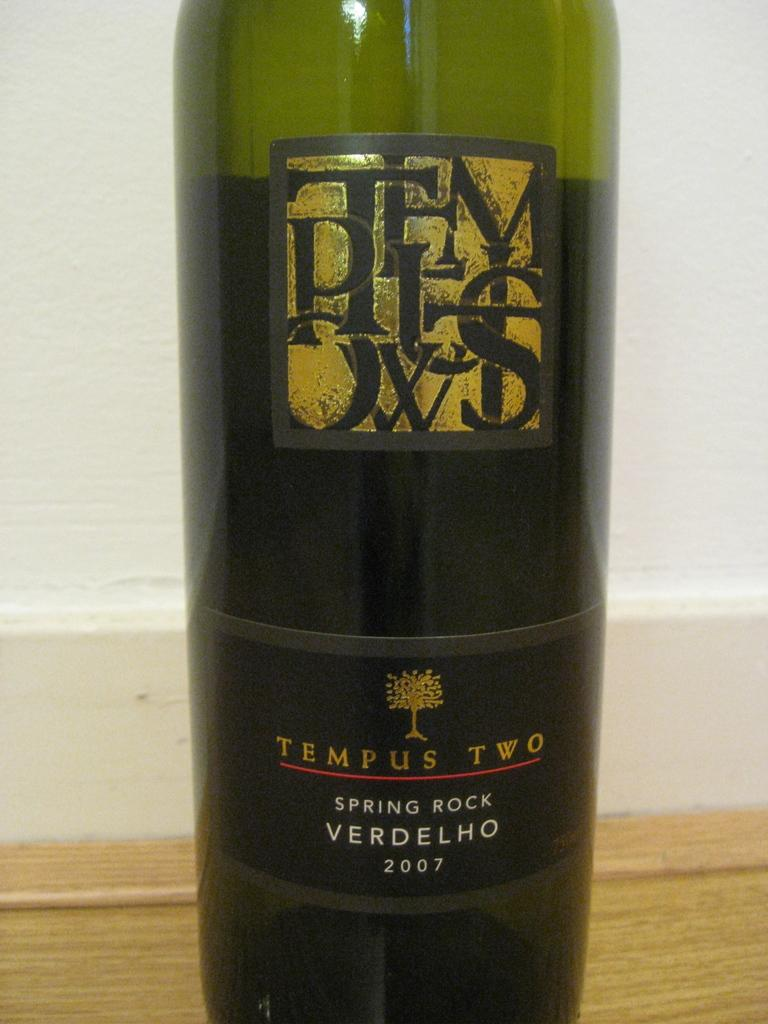<image>
Provide a brief description of the given image. A bottle of Spring Rock Verdelho sits open on the counter 